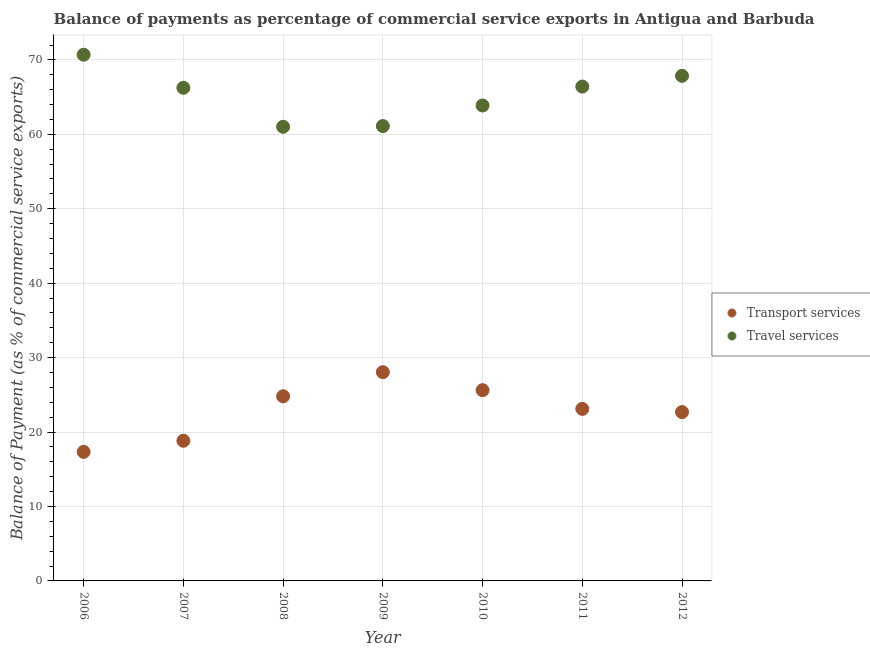How many different coloured dotlines are there?
Give a very brief answer. 2. Is the number of dotlines equal to the number of legend labels?
Your answer should be very brief. Yes. What is the balance of payments of transport services in 2007?
Your response must be concise. 18.83. Across all years, what is the maximum balance of payments of transport services?
Provide a succinct answer. 28.04. Across all years, what is the minimum balance of payments of transport services?
Ensure brevity in your answer.  17.34. In which year was the balance of payments of travel services maximum?
Provide a short and direct response. 2006. In which year was the balance of payments of transport services minimum?
Make the answer very short. 2006. What is the total balance of payments of transport services in the graph?
Your answer should be very brief. 160.44. What is the difference between the balance of payments of transport services in 2007 and that in 2011?
Offer a terse response. -4.29. What is the difference between the balance of payments of travel services in 2011 and the balance of payments of transport services in 2007?
Provide a succinct answer. 47.59. What is the average balance of payments of travel services per year?
Your response must be concise. 65.32. In the year 2007, what is the difference between the balance of payments of transport services and balance of payments of travel services?
Keep it short and to the point. -47.42. What is the ratio of the balance of payments of transport services in 2009 to that in 2011?
Keep it short and to the point. 1.21. Is the difference between the balance of payments of transport services in 2007 and 2008 greater than the difference between the balance of payments of travel services in 2007 and 2008?
Provide a short and direct response. No. What is the difference between the highest and the second highest balance of payments of travel services?
Your response must be concise. 2.84. What is the difference between the highest and the lowest balance of payments of travel services?
Your response must be concise. 9.68. Does the balance of payments of travel services monotonically increase over the years?
Provide a short and direct response. No. What is the difference between two consecutive major ticks on the Y-axis?
Make the answer very short. 10. Where does the legend appear in the graph?
Your answer should be compact. Center right. How many legend labels are there?
Your response must be concise. 2. How are the legend labels stacked?
Provide a succinct answer. Vertical. What is the title of the graph?
Your answer should be very brief. Balance of payments as percentage of commercial service exports in Antigua and Barbuda. What is the label or title of the Y-axis?
Ensure brevity in your answer.  Balance of Payment (as % of commercial service exports). What is the Balance of Payment (as % of commercial service exports) in Transport services in 2006?
Your answer should be compact. 17.34. What is the Balance of Payment (as % of commercial service exports) of Travel services in 2006?
Ensure brevity in your answer.  70.69. What is the Balance of Payment (as % of commercial service exports) in Transport services in 2007?
Your answer should be very brief. 18.83. What is the Balance of Payment (as % of commercial service exports) in Travel services in 2007?
Make the answer very short. 66.25. What is the Balance of Payment (as % of commercial service exports) of Transport services in 2008?
Your answer should be very brief. 24.81. What is the Balance of Payment (as % of commercial service exports) in Travel services in 2008?
Provide a short and direct response. 61.02. What is the Balance of Payment (as % of commercial service exports) of Transport services in 2009?
Ensure brevity in your answer.  28.04. What is the Balance of Payment (as % of commercial service exports) in Travel services in 2009?
Offer a terse response. 61.11. What is the Balance of Payment (as % of commercial service exports) in Transport services in 2010?
Provide a succinct answer. 25.63. What is the Balance of Payment (as % of commercial service exports) in Travel services in 2010?
Give a very brief answer. 63.88. What is the Balance of Payment (as % of commercial service exports) in Transport services in 2011?
Your response must be concise. 23.11. What is the Balance of Payment (as % of commercial service exports) in Travel services in 2011?
Give a very brief answer. 66.42. What is the Balance of Payment (as % of commercial service exports) in Transport services in 2012?
Your answer should be compact. 22.69. What is the Balance of Payment (as % of commercial service exports) of Travel services in 2012?
Offer a very short reply. 67.86. Across all years, what is the maximum Balance of Payment (as % of commercial service exports) of Transport services?
Your response must be concise. 28.04. Across all years, what is the maximum Balance of Payment (as % of commercial service exports) in Travel services?
Ensure brevity in your answer.  70.69. Across all years, what is the minimum Balance of Payment (as % of commercial service exports) of Transport services?
Keep it short and to the point. 17.34. Across all years, what is the minimum Balance of Payment (as % of commercial service exports) of Travel services?
Ensure brevity in your answer.  61.02. What is the total Balance of Payment (as % of commercial service exports) in Transport services in the graph?
Provide a succinct answer. 160.44. What is the total Balance of Payment (as % of commercial service exports) of Travel services in the graph?
Ensure brevity in your answer.  457.22. What is the difference between the Balance of Payment (as % of commercial service exports) of Transport services in 2006 and that in 2007?
Offer a terse response. -1.49. What is the difference between the Balance of Payment (as % of commercial service exports) of Travel services in 2006 and that in 2007?
Offer a very short reply. 4.44. What is the difference between the Balance of Payment (as % of commercial service exports) in Transport services in 2006 and that in 2008?
Your answer should be compact. -7.47. What is the difference between the Balance of Payment (as % of commercial service exports) of Travel services in 2006 and that in 2008?
Ensure brevity in your answer.  9.68. What is the difference between the Balance of Payment (as % of commercial service exports) in Transport services in 2006 and that in 2009?
Your answer should be compact. -10.7. What is the difference between the Balance of Payment (as % of commercial service exports) in Travel services in 2006 and that in 2009?
Give a very brief answer. 9.58. What is the difference between the Balance of Payment (as % of commercial service exports) of Transport services in 2006 and that in 2010?
Provide a succinct answer. -8.29. What is the difference between the Balance of Payment (as % of commercial service exports) in Travel services in 2006 and that in 2010?
Give a very brief answer. 6.82. What is the difference between the Balance of Payment (as % of commercial service exports) in Transport services in 2006 and that in 2011?
Keep it short and to the point. -5.77. What is the difference between the Balance of Payment (as % of commercial service exports) of Travel services in 2006 and that in 2011?
Ensure brevity in your answer.  4.28. What is the difference between the Balance of Payment (as % of commercial service exports) in Transport services in 2006 and that in 2012?
Your answer should be very brief. -5.35. What is the difference between the Balance of Payment (as % of commercial service exports) of Travel services in 2006 and that in 2012?
Ensure brevity in your answer.  2.84. What is the difference between the Balance of Payment (as % of commercial service exports) in Transport services in 2007 and that in 2008?
Make the answer very short. -5.98. What is the difference between the Balance of Payment (as % of commercial service exports) of Travel services in 2007 and that in 2008?
Keep it short and to the point. 5.23. What is the difference between the Balance of Payment (as % of commercial service exports) in Transport services in 2007 and that in 2009?
Provide a short and direct response. -9.22. What is the difference between the Balance of Payment (as % of commercial service exports) of Travel services in 2007 and that in 2009?
Give a very brief answer. 5.14. What is the difference between the Balance of Payment (as % of commercial service exports) of Transport services in 2007 and that in 2010?
Make the answer very short. -6.8. What is the difference between the Balance of Payment (as % of commercial service exports) in Travel services in 2007 and that in 2010?
Your response must be concise. 2.37. What is the difference between the Balance of Payment (as % of commercial service exports) of Transport services in 2007 and that in 2011?
Give a very brief answer. -4.29. What is the difference between the Balance of Payment (as % of commercial service exports) of Travel services in 2007 and that in 2011?
Offer a terse response. -0.17. What is the difference between the Balance of Payment (as % of commercial service exports) of Transport services in 2007 and that in 2012?
Provide a succinct answer. -3.86. What is the difference between the Balance of Payment (as % of commercial service exports) of Travel services in 2007 and that in 2012?
Ensure brevity in your answer.  -1.61. What is the difference between the Balance of Payment (as % of commercial service exports) in Transport services in 2008 and that in 2009?
Give a very brief answer. -3.24. What is the difference between the Balance of Payment (as % of commercial service exports) of Travel services in 2008 and that in 2009?
Give a very brief answer. -0.09. What is the difference between the Balance of Payment (as % of commercial service exports) of Transport services in 2008 and that in 2010?
Provide a short and direct response. -0.82. What is the difference between the Balance of Payment (as % of commercial service exports) in Travel services in 2008 and that in 2010?
Ensure brevity in your answer.  -2.86. What is the difference between the Balance of Payment (as % of commercial service exports) in Transport services in 2008 and that in 2011?
Provide a short and direct response. 1.7. What is the difference between the Balance of Payment (as % of commercial service exports) of Travel services in 2008 and that in 2011?
Provide a succinct answer. -5.4. What is the difference between the Balance of Payment (as % of commercial service exports) in Transport services in 2008 and that in 2012?
Your response must be concise. 2.12. What is the difference between the Balance of Payment (as % of commercial service exports) of Travel services in 2008 and that in 2012?
Provide a succinct answer. -6.84. What is the difference between the Balance of Payment (as % of commercial service exports) of Transport services in 2009 and that in 2010?
Provide a succinct answer. 2.42. What is the difference between the Balance of Payment (as % of commercial service exports) of Travel services in 2009 and that in 2010?
Provide a short and direct response. -2.77. What is the difference between the Balance of Payment (as % of commercial service exports) in Transport services in 2009 and that in 2011?
Make the answer very short. 4.93. What is the difference between the Balance of Payment (as % of commercial service exports) in Travel services in 2009 and that in 2011?
Offer a terse response. -5.3. What is the difference between the Balance of Payment (as % of commercial service exports) of Transport services in 2009 and that in 2012?
Keep it short and to the point. 5.36. What is the difference between the Balance of Payment (as % of commercial service exports) in Travel services in 2009 and that in 2012?
Offer a terse response. -6.75. What is the difference between the Balance of Payment (as % of commercial service exports) in Transport services in 2010 and that in 2011?
Provide a short and direct response. 2.51. What is the difference between the Balance of Payment (as % of commercial service exports) in Travel services in 2010 and that in 2011?
Make the answer very short. -2.54. What is the difference between the Balance of Payment (as % of commercial service exports) of Transport services in 2010 and that in 2012?
Provide a succinct answer. 2.94. What is the difference between the Balance of Payment (as % of commercial service exports) of Travel services in 2010 and that in 2012?
Provide a short and direct response. -3.98. What is the difference between the Balance of Payment (as % of commercial service exports) in Transport services in 2011 and that in 2012?
Keep it short and to the point. 0.43. What is the difference between the Balance of Payment (as % of commercial service exports) in Travel services in 2011 and that in 2012?
Ensure brevity in your answer.  -1.44. What is the difference between the Balance of Payment (as % of commercial service exports) in Transport services in 2006 and the Balance of Payment (as % of commercial service exports) in Travel services in 2007?
Keep it short and to the point. -48.91. What is the difference between the Balance of Payment (as % of commercial service exports) in Transport services in 2006 and the Balance of Payment (as % of commercial service exports) in Travel services in 2008?
Your answer should be compact. -43.68. What is the difference between the Balance of Payment (as % of commercial service exports) of Transport services in 2006 and the Balance of Payment (as % of commercial service exports) of Travel services in 2009?
Your answer should be compact. -43.77. What is the difference between the Balance of Payment (as % of commercial service exports) of Transport services in 2006 and the Balance of Payment (as % of commercial service exports) of Travel services in 2010?
Provide a succinct answer. -46.54. What is the difference between the Balance of Payment (as % of commercial service exports) of Transport services in 2006 and the Balance of Payment (as % of commercial service exports) of Travel services in 2011?
Offer a very short reply. -49.08. What is the difference between the Balance of Payment (as % of commercial service exports) in Transport services in 2006 and the Balance of Payment (as % of commercial service exports) in Travel services in 2012?
Provide a short and direct response. -50.52. What is the difference between the Balance of Payment (as % of commercial service exports) of Transport services in 2007 and the Balance of Payment (as % of commercial service exports) of Travel services in 2008?
Offer a very short reply. -42.19. What is the difference between the Balance of Payment (as % of commercial service exports) of Transport services in 2007 and the Balance of Payment (as % of commercial service exports) of Travel services in 2009?
Your response must be concise. -42.28. What is the difference between the Balance of Payment (as % of commercial service exports) of Transport services in 2007 and the Balance of Payment (as % of commercial service exports) of Travel services in 2010?
Ensure brevity in your answer.  -45.05. What is the difference between the Balance of Payment (as % of commercial service exports) of Transport services in 2007 and the Balance of Payment (as % of commercial service exports) of Travel services in 2011?
Your response must be concise. -47.59. What is the difference between the Balance of Payment (as % of commercial service exports) in Transport services in 2007 and the Balance of Payment (as % of commercial service exports) in Travel services in 2012?
Give a very brief answer. -49.03. What is the difference between the Balance of Payment (as % of commercial service exports) in Transport services in 2008 and the Balance of Payment (as % of commercial service exports) in Travel services in 2009?
Keep it short and to the point. -36.3. What is the difference between the Balance of Payment (as % of commercial service exports) in Transport services in 2008 and the Balance of Payment (as % of commercial service exports) in Travel services in 2010?
Make the answer very short. -39.07. What is the difference between the Balance of Payment (as % of commercial service exports) of Transport services in 2008 and the Balance of Payment (as % of commercial service exports) of Travel services in 2011?
Provide a short and direct response. -41.61. What is the difference between the Balance of Payment (as % of commercial service exports) in Transport services in 2008 and the Balance of Payment (as % of commercial service exports) in Travel services in 2012?
Your response must be concise. -43.05. What is the difference between the Balance of Payment (as % of commercial service exports) of Transport services in 2009 and the Balance of Payment (as % of commercial service exports) of Travel services in 2010?
Give a very brief answer. -35.83. What is the difference between the Balance of Payment (as % of commercial service exports) of Transport services in 2009 and the Balance of Payment (as % of commercial service exports) of Travel services in 2011?
Make the answer very short. -38.37. What is the difference between the Balance of Payment (as % of commercial service exports) of Transport services in 2009 and the Balance of Payment (as % of commercial service exports) of Travel services in 2012?
Give a very brief answer. -39.81. What is the difference between the Balance of Payment (as % of commercial service exports) in Transport services in 2010 and the Balance of Payment (as % of commercial service exports) in Travel services in 2011?
Offer a terse response. -40.79. What is the difference between the Balance of Payment (as % of commercial service exports) of Transport services in 2010 and the Balance of Payment (as % of commercial service exports) of Travel services in 2012?
Provide a short and direct response. -42.23. What is the difference between the Balance of Payment (as % of commercial service exports) of Transport services in 2011 and the Balance of Payment (as % of commercial service exports) of Travel services in 2012?
Your answer should be very brief. -44.75. What is the average Balance of Payment (as % of commercial service exports) of Transport services per year?
Provide a succinct answer. 22.92. What is the average Balance of Payment (as % of commercial service exports) of Travel services per year?
Provide a short and direct response. 65.32. In the year 2006, what is the difference between the Balance of Payment (as % of commercial service exports) of Transport services and Balance of Payment (as % of commercial service exports) of Travel services?
Make the answer very short. -53.35. In the year 2007, what is the difference between the Balance of Payment (as % of commercial service exports) of Transport services and Balance of Payment (as % of commercial service exports) of Travel services?
Provide a short and direct response. -47.42. In the year 2008, what is the difference between the Balance of Payment (as % of commercial service exports) in Transport services and Balance of Payment (as % of commercial service exports) in Travel services?
Provide a succinct answer. -36.21. In the year 2009, what is the difference between the Balance of Payment (as % of commercial service exports) of Transport services and Balance of Payment (as % of commercial service exports) of Travel services?
Your answer should be very brief. -33.07. In the year 2010, what is the difference between the Balance of Payment (as % of commercial service exports) in Transport services and Balance of Payment (as % of commercial service exports) in Travel services?
Offer a terse response. -38.25. In the year 2011, what is the difference between the Balance of Payment (as % of commercial service exports) of Transport services and Balance of Payment (as % of commercial service exports) of Travel services?
Keep it short and to the point. -43.3. In the year 2012, what is the difference between the Balance of Payment (as % of commercial service exports) of Transport services and Balance of Payment (as % of commercial service exports) of Travel services?
Give a very brief answer. -45.17. What is the ratio of the Balance of Payment (as % of commercial service exports) of Transport services in 2006 to that in 2007?
Your response must be concise. 0.92. What is the ratio of the Balance of Payment (as % of commercial service exports) in Travel services in 2006 to that in 2007?
Provide a short and direct response. 1.07. What is the ratio of the Balance of Payment (as % of commercial service exports) of Transport services in 2006 to that in 2008?
Provide a succinct answer. 0.7. What is the ratio of the Balance of Payment (as % of commercial service exports) in Travel services in 2006 to that in 2008?
Give a very brief answer. 1.16. What is the ratio of the Balance of Payment (as % of commercial service exports) of Transport services in 2006 to that in 2009?
Your answer should be very brief. 0.62. What is the ratio of the Balance of Payment (as % of commercial service exports) of Travel services in 2006 to that in 2009?
Your answer should be compact. 1.16. What is the ratio of the Balance of Payment (as % of commercial service exports) in Transport services in 2006 to that in 2010?
Ensure brevity in your answer.  0.68. What is the ratio of the Balance of Payment (as % of commercial service exports) in Travel services in 2006 to that in 2010?
Provide a short and direct response. 1.11. What is the ratio of the Balance of Payment (as % of commercial service exports) of Transport services in 2006 to that in 2011?
Your response must be concise. 0.75. What is the ratio of the Balance of Payment (as % of commercial service exports) of Travel services in 2006 to that in 2011?
Offer a terse response. 1.06. What is the ratio of the Balance of Payment (as % of commercial service exports) of Transport services in 2006 to that in 2012?
Your response must be concise. 0.76. What is the ratio of the Balance of Payment (as % of commercial service exports) in Travel services in 2006 to that in 2012?
Your answer should be compact. 1.04. What is the ratio of the Balance of Payment (as % of commercial service exports) in Transport services in 2007 to that in 2008?
Ensure brevity in your answer.  0.76. What is the ratio of the Balance of Payment (as % of commercial service exports) in Travel services in 2007 to that in 2008?
Give a very brief answer. 1.09. What is the ratio of the Balance of Payment (as % of commercial service exports) of Transport services in 2007 to that in 2009?
Your answer should be very brief. 0.67. What is the ratio of the Balance of Payment (as % of commercial service exports) in Travel services in 2007 to that in 2009?
Your answer should be compact. 1.08. What is the ratio of the Balance of Payment (as % of commercial service exports) in Transport services in 2007 to that in 2010?
Offer a terse response. 0.73. What is the ratio of the Balance of Payment (as % of commercial service exports) of Travel services in 2007 to that in 2010?
Ensure brevity in your answer.  1.04. What is the ratio of the Balance of Payment (as % of commercial service exports) in Transport services in 2007 to that in 2011?
Offer a very short reply. 0.81. What is the ratio of the Balance of Payment (as % of commercial service exports) of Travel services in 2007 to that in 2011?
Ensure brevity in your answer.  1. What is the ratio of the Balance of Payment (as % of commercial service exports) in Transport services in 2007 to that in 2012?
Your answer should be very brief. 0.83. What is the ratio of the Balance of Payment (as % of commercial service exports) of Travel services in 2007 to that in 2012?
Offer a very short reply. 0.98. What is the ratio of the Balance of Payment (as % of commercial service exports) of Transport services in 2008 to that in 2009?
Ensure brevity in your answer.  0.88. What is the ratio of the Balance of Payment (as % of commercial service exports) of Transport services in 2008 to that in 2010?
Give a very brief answer. 0.97. What is the ratio of the Balance of Payment (as % of commercial service exports) in Travel services in 2008 to that in 2010?
Your answer should be compact. 0.96. What is the ratio of the Balance of Payment (as % of commercial service exports) in Transport services in 2008 to that in 2011?
Provide a succinct answer. 1.07. What is the ratio of the Balance of Payment (as % of commercial service exports) in Travel services in 2008 to that in 2011?
Give a very brief answer. 0.92. What is the ratio of the Balance of Payment (as % of commercial service exports) in Transport services in 2008 to that in 2012?
Give a very brief answer. 1.09. What is the ratio of the Balance of Payment (as % of commercial service exports) in Travel services in 2008 to that in 2012?
Keep it short and to the point. 0.9. What is the ratio of the Balance of Payment (as % of commercial service exports) in Transport services in 2009 to that in 2010?
Keep it short and to the point. 1.09. What is the ratio of the Balance of Payment (as % of commercial service exports) in Travel services in 2009 to that in 2010?
Provide a succinct answer. 0.96. What is the ratio of the Balance of Payment (as % of commercial service exports) of Transport services in 2009 to that in 2011?
Your response must be concise. 1.21. What is the ratio of the Balance of Payment (as % of commercial service exports) in Travel services in 2009 to that in 2011?
Keep it short and to the point. 0.92. What is the ratio of the Balance of Payment (as % of commercial service exports) of Transport services in 2009 to that in 2012?
Keep it short and to the point. 1.24. What is the ratio of the Balance of Payment (as % of commercial service exports) of Travel services in 2009 to that in 2012?
Offer a very short reply. 0.9. What is the ratio of the Balance of Payment (as % of commercial service exports) of Transport services in 2010 to that in 2011?
Your answer should be very brief. 1.11. What is the ratio of the Balance of Payment (as % of commercial service exports) in Travel services in 2010 to that in 2011?
Offer a very short reply. 0.96. What is the ratio of the Balance of Payment (as % of commercial service exports) of Transport services in 2010 to that in 2012?
Your response must be concise. 1.13. What is the ratio of the Balance of Payment (as % of commercial service exports) of Travel services in 2010 to that in 2012?
Your answer should be compact. 0.94. What is the ratio of the Balance of Payment (as % of commercial service exports) of Transport services in 2011 to that in 2012?
Offer a terse response. 1.02. What is the ratio of the Balance of Payment (as % of commercial service exports) in Travel services in 2011 to that in 2012?
Your answer should be very brief. 0.98. What is the difference between the highest and the second highest Balance of Payment (as % of commercial service exports) in Transport services?
Keep it short and to the point. 2.42. What is the difference between the highest and the second highest Balance of Payment (as % of commercial service exports) of Travel services?
Provide a short and direct response. 2.84. What is the difference between the highest and the lowest Balance of Payment (as % of commercial service exports) in Transport services?
Keep it short and to the point. 10.7. What is the difference between the highest and the lowest Balance of Payment (as % of commercial service exports) of Travel services?
Ensure brevity in your answer.  9.68. 